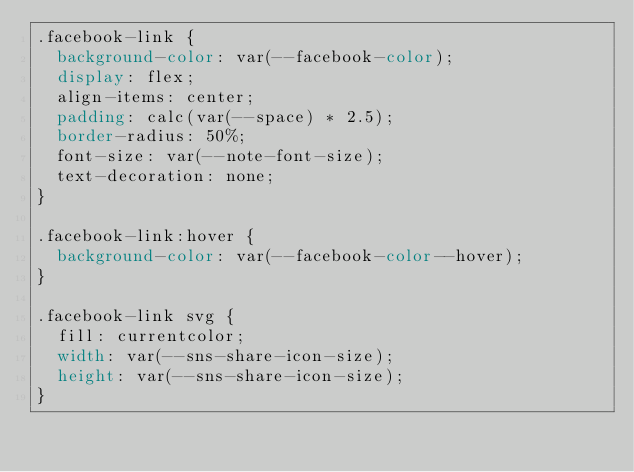Convert code to text. <code><loc_0><loc_0><loc_500><loc_500><_CSS_>.facebook-link {
  background-color: var(--facebook-color);
  display: flex;
  align-items: center;
  padding: calc(var(--space) * 2.5);
  border-radius: 50%;
  font-size: var(--note-font-size);
  text-decoration: none;
}

.facebook-link:hover {
  background-color: var(--facebook-color--hover);
}

.facebook-link svg {
  fill: currentcolor;
  width: var(--sns-share-icon-size);
  height: var(--sns-share-icon-size);
}
</code> 